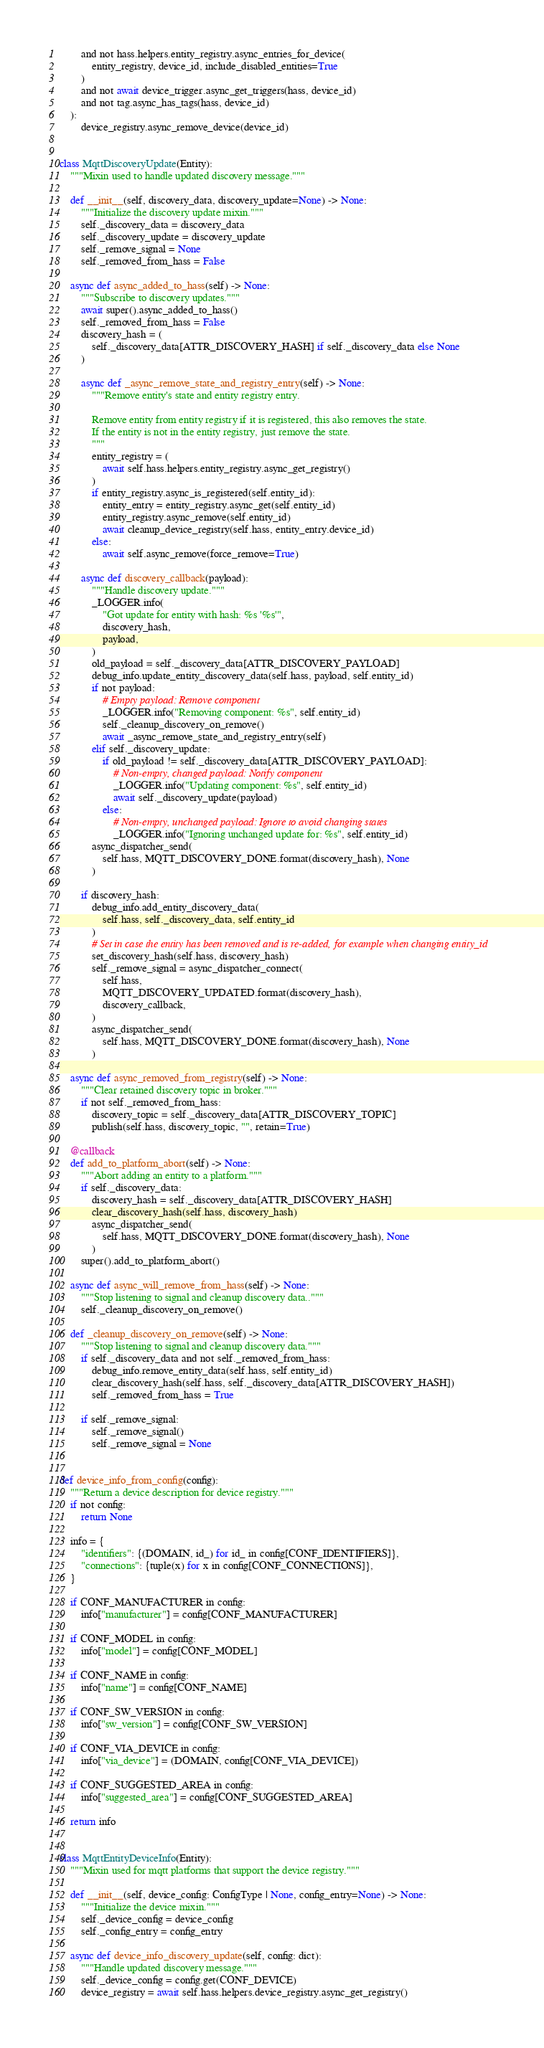<code> <loc_0><loc_0><loc_500><loc_500><_Python_>        and not hass.helpers.entity_registry.async_entries_for_device(
            entity_registry, device_id, include_disabled_entities=True
        )
        and not await device_trigger.async_get_triggers(hass, device_id)
        and not tag.async_has_tags(hass, device_id)
    ):
        device_registry.async_remove_device(device_id)


class MqttDiscoveryUpdate(Entity):
    """Mixin used to handle updated discovery message."""

    def __init__(self, discovery_data, discovery_update=None) -> None:
        """Initialize the discovery update mixin."""
        self._discovery_data = discovery_data
        self._discovery_update = discovery_update
        self._remove_signal = None
        self._removed_from_hass = False

    async def async_added_to_hass(self) -> None:
        """Subscribe to discovery updates."""
        await super().async_added_to_hass()
        self._removed_from_hass = False
        discovery_hash = (
            self._discovery_data[ATTR_DISCOVERY_HASH] if self._discovery_data else None
        )

        async def _async_remove_state_and_registry_entry(self) -> None:
            """Remove entity's state and entity registry entry.

            Remove entity from entity registry if it is registered, this also removes the state.
            If the entity is not in the entity registry, just remove the state.
            """
            entity_registry = (
                await self.hass.helpers.entity_registry.async_get_registry()
            )
            if entity_registry.async_is_registered(self.entity_id):
                entity_entry = entity_registry.async_get(self.entity_id)
                entity_registry.async_remove(self.entity_id)
                await cleanup_device_registry(self.hass, entity_entry.device_id)
            else:
                await self.async_remove(force_remove=True)

        async def discovery_callback(payload):
            """Handle discovery update."""
            _LOGGER.info(
                "Got update for entity with hash: %s '%s'",
                discovery_hash,
                payload,
            )
            old_payload = self._discovery_data[ATTR_DISCOVERY_PAYLOAD]
            debug_info.update_entity_discovery_data(self.hass, payload, self.entity_id)
            if not payload:
                # Empty payload: Remove component
                _LOGGER.info("Removing component: %s", self.entity_id)
                self._cleanup_discovery_on_remove()
                await _async_remove_state_and_registry_entry(self)
            elif self._discovery_update:
                if old_payload != self._discovery_data[ATTR_DISCOVERY_PAYLOAD]:
                    # Non-empty, changed payload: Notify component
                    _LOGGER.info("Updating component: %s", self.entity_id)
                    await self._discovery_update(payload)
                else:
                    # Non-empty, unchanged payload: Ignore to avoid changing states
                    _LOGGER.info("Ignoring unchanged update for: %s", self.entity_id)
            async_dispatcher_send(
                self.hass, MQTT_DISCOVERY_DONE.format(discovery_hash), None
            )

        if discovery_hash:
            debug_info.add_entity_discovery_data(
                self.hass, self._discovery_data, self.entity_id
            )
            # Set in case the entity has been removed and is re-added, for example when changing entity_id
            set_discovery_hash(self.hass, discovery_hash)
            self._remove_signal = async_dispatcher_connect(
                self.hass,
                MQTT_DISCOVERY_UPDATED.format(discovery_hash),
                discovery_callback,
            )
            async_dispatcher_send(
                self.hass, MQTT_DISCOVERY_DONE.format(discovery_hash), None
            )

    async def async_removed_from_registry(self) -> None:
        """Clear retained discovery topic in broker."""
        if not self._removed_from_hass:
            discovery_topic = self._discovery_data[ATTR_DISCOVERY_TOPIC]
            publish(self.hass, discovery_topic, "", retain=True)

    @callback
    def add_to_platform_abort(self) -> None:
        """Abort adding an entity to a platform."""
        if self._discovery_data:
            discovery_hash = self._discovery_data[ATTR_DISCOVERY_HASH]
            clear_discovery_hash(self.hass, discovery_hash)
            async_dispatcher_send(
                self.hass, MQTT_DISCOVERY_DONE.format(discovery_hash), None
            )
        super().add_to_platform_abort()

    async def async_will_remove_from_hass(self) -> None:
        """Stop listening to signal and cleanup discovery data.."""
        self._cleanup_discovery_on_remove()

    def _cleanup_discovery_on_remove(self) -> None:
        """Stop listening to signal and cleanup discovery data."""
        if self._discovery_data and not self._removed_from_hass:
            debug_info.remove_entity_data(self.hass, self.entity_id)
            clear_discovery_hash(self.hass, self._discovery_data[ATTR_DISCOVERY_HASH])
            self._removed_from_hass = True

        if self._remove_signal:
            self._remove_signal()
            self._remove_signal = None


def device_info_from_config(config):
    """Return a device description for device registry."""
    if not config:
        return None

    info = {
        "identifiers": {(DOMAIN, id_) for id_ in config[CONF_IDENTIFIERS]},
        "connections": {tuple(x) for x in config[CONF_CONNECTIONS]},
    }

    if CONF_MANUFACTURER in config:
        info["manufacturer"] = config[CONF_MANUFACTURER]

    if CONF_MODEL in config:
        info["model"] = config[CONF_MODEL]

    if CONF_NAME in config:
        info["name"] = config[CONF_NAME]

    if CONF_SW_VERSION in config:
        info["sw_version"] = config[CONF_SW_VERSION]

    if CONF_VIA_DEVICE in config:
        info["via_device"] = (DOMAIN, config[CONF_VIA_DEVICE])

    if CONF_SUGGESTED_AREA in config:
        info["suggested_area"] = config[CONF_SUGGESTED_AREA]

    return info


class MqttEntityDeviceInfo(Entity):
    """Mixin used for mqtt platforms that support the device registry."""

    def __init__(self, device_config: ConfigType | None, config_entry=None) -> None:
        """Initialize the device mixin."""
        self._device_config = device_config
        self._config_entry = config_entry

    async def device_info_discovery_update(self, config: dict):
        """Handle updated discovery message."""
        self._device_config = config.get(CONF_DEVICE)
        device_registry = await self.hass.helpers.device_registry.async_get_registry()</code> 